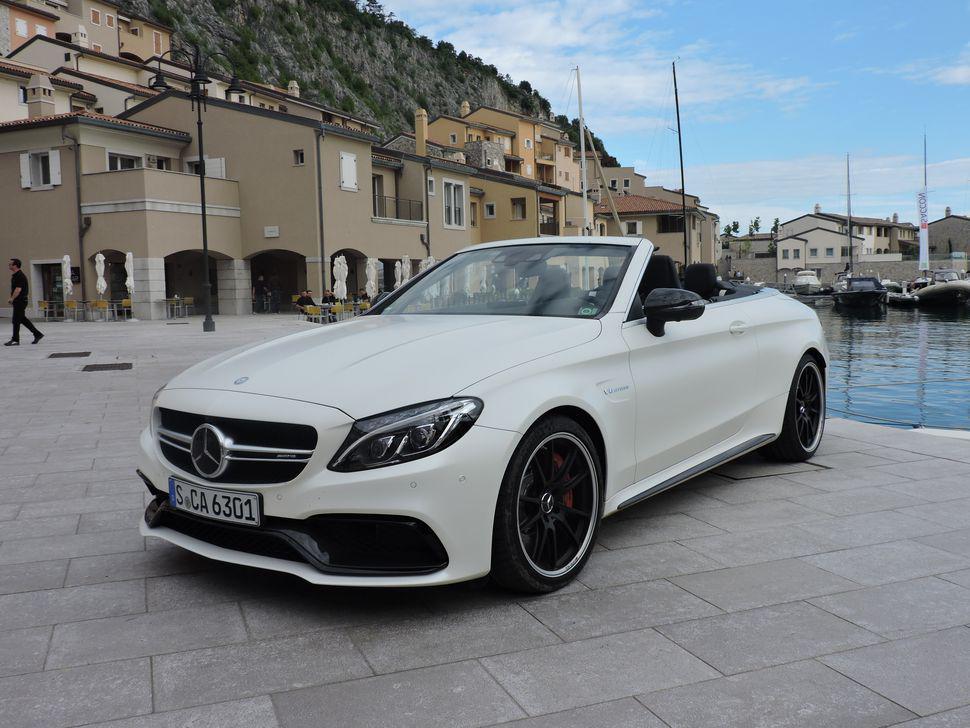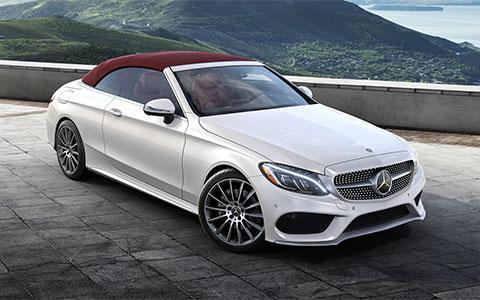The first image is the image on the left, the second image is the image on the right. Assess this claim about the two images: "One image shows a white convertible with its top covered.". Correct or not? Answer yes or no. Yes. The first image is the image on the left, the second image is the image on the right. For the images shown, is this caption "In one of the images there is a convertible parked outside with a building visible in the background." true? Answer yes or no. Yes. 